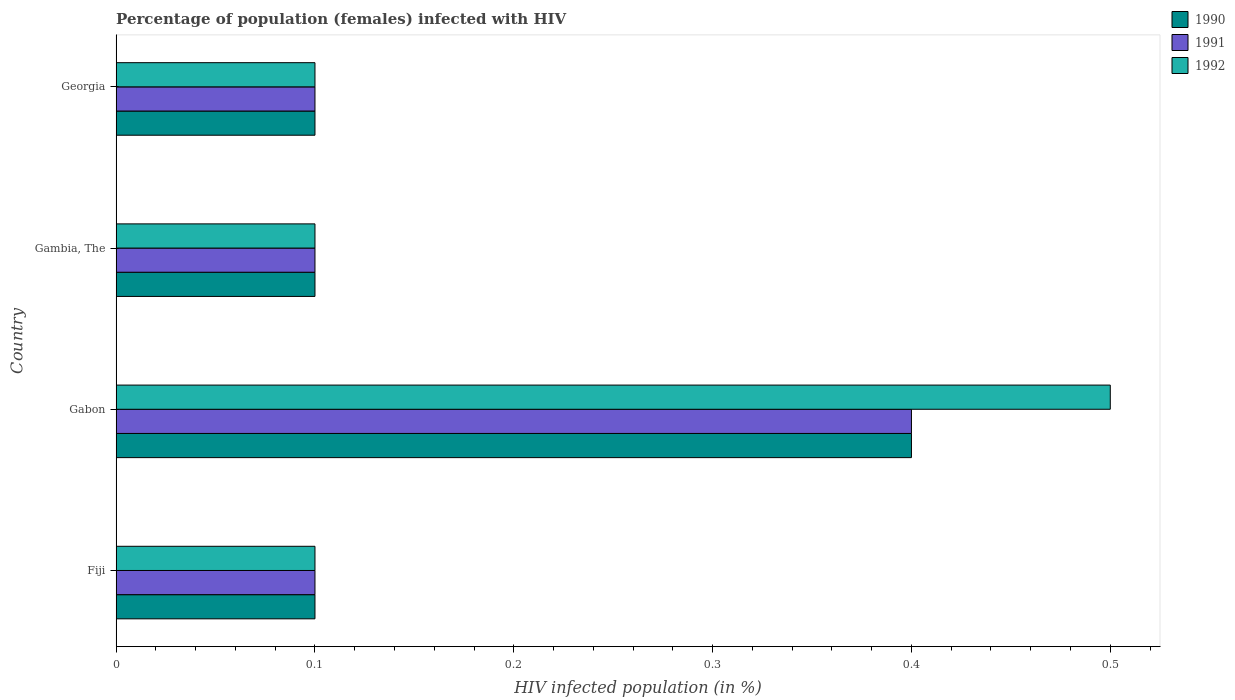How many different coloured bars are there?
Offer a terse response. 3. Are the number of bars on each tick of the Y-axis equal?
Offer a terse response. Yes. How many bars are there on the 1st tick from the bottom?
Offer a very short reply. 3. What is the label of the 4th group of bars from the top?
Your answer should be compact. Fiji. In how many cases, is the number of bars for a given country not equal to the number of legend labels?
Ensure brevity in your answer.  0. Across all countries, what is the minimum percentage of HIV infected female population in 1991?
Your response must be concise. 0.1. In which country was the percentage of HIV infected female population in 1990 maximum?
Make the answer very short. Gabon. In which country was the percentage of HIV infected female population in 1991 minimum?
Make the answer very short. Fiji. What is the total percentage of HIV infected female population in 1991 in the graph?
Your answer should be very brief. 0.7. What is the difference between the percentage of HIV infected female population in 1992 in Fiji and that in Gambia, The?
Your response must be concise. 0. What is the difference between the percentage of HIV infected female population in 1990 in Fiji and the percentage of HIV infected female population in 1991 in Georgia?
Make the answer very short. 0. What is the average percentage of HIV infected female population in 1992 per country?
Offer a terse response. 0.2. In how many countries, is the percentage of HIV infected female population in 1991 greater than 0.46 %?
Offer a terse response. 0. Is the difference between the percentage of HIV infected female population in 1990 in Fiji and Georgia greater than the difference between the percentage of HIV infected female population in 1992 in Fiji and Georgia?
Give a very brief answer. No. What is the difference between the highest and the second highest percentage of HIV infected female population in 1992?
Provide a succinct answer. 0.4. What is the difference between the highest and the lowest percentage of HIV infected female population in 1990?
Make the answer very short. 0.3. What does the 2nd bar from the bottom in Georgia represents?
Your response must be concise. 1991. Are all the bars in the graph horizontal?
Offer a very short reply. Yes. Are the values on the major ticks of X-axis written in scientific E-notation?
Your response must be concise. No. Does the graph contain any zero values?
Give a very brief answer. No. How many legend labels are there?
Your answer should be very brief. 3. How are the legend labels stacked?
Your response must be concise. Vertical. What is the title of the graph?
Your answer should be compact. Percentage of population (females) infected with HIV. Does "1967" appear as one of the legend labels in the graph?
Ensure brevity in your answer.  No. What is the label or title of the X-axis?
Give a very brief answer. HIV infected population (in %). What is the label or title of the Y-axis?
Make the answer very short. Country. What is the HIV infected population (in %) of 1990 in Fiji?
Offer a very short reply. 0.1. What is the HIV infected population (in %) in 1992 in Fiji?
Keep it short and to the point. 0.1. What is the HIV infected population (in %) of 1990 in Gabon?
Your answer should be very brief. 0.4. What is the HIV infected population (in %) of 1992 in Gabon?
Provide a succinct answer. 0.5. What is the HIV infected population (in %) in 1992 in Gambia, The?
Offer a very short reply. 0.1. What is the HIV infected population (in %) in 1992 in Georgia?
Offer a very short reply. 0.1. Across all countries, what is the maximum HIV infected population (in %) in 1990?
Your response must be concise. 0.4. Across all countries, what is the minimum HIV infected population (in %) of 1991?
Offer a terse response. 0.1. What is the total HIV infected population (in %) of 1990 in the graph?
Provide a short and direct response. 0.7. What is the total HIV infected population (in %) of 1991 in the graph?
Your response must be concise. 0.7. What is the total HIV infected population (in %) of 1992 in the graph?
Provide a succinct answer. 0.8. What is the difference between the HIV infected population (in %) of 1991 in Fiji and that in Gambia, The?
Give a very brief answer. 0. What is the difference between the HIV infected population (in %) of 1990 in Gabon and that in Gambia, The?
Ensure brevity in your answer.  0.3. What is the difference between the HIV infected population (in %) of 1991 in Gabon and that in Gambia, The?
Keep it short and to the point. 0.3. What is the difference between the HIV infected population (in %) in 1990 in Gabon and that in Georgia?
Provide a short and direct response. 0.3. What is the difference between the HIV infected population (in %) of 1991 in Fiji and the HIV infected population (in %) of 1992 in Gabon?
Your response must be concise. -0.4. What is the difference between the HIV infected population (in %) of 1990 in Fiji and the HIV infected population (in %) of 1992 in Gambia, The?
Offer a very short reply. 0. What is the difference between the HIV infected population (in %) in 1990 in Fiji and the HIV infected population (in %) in 1991 in Georgia?
Ensure brevity in your answer.  0. What is the difference between the HIV infected population (in %) in 1990 in Fiji and the HIV infected population (in %) in 1992 in Georgia?
Your response must be concise. 0. What is the difference between the HIV infected population (in %) of 1991 in Gabon and the HIV infected population (in %) of 1992 in Georgia?
Your answer should be very brief. 0.3. What is the difference between the HIV infected population (in %) of 1990 in Gambia, The and the HIV infected population (in %) of 1991 in Georgia?
Offer a very short reply. 0. What is the difference between the HIV infected population (in %) in 1990 in Gambia, The and the HIV infected population (in %) in 1992 in Georgia?
Your answer should be very brief. 0. What is the difference between the HIV infected population (in %) in 1991 in Gambia, The and the HIV infected population (in %) in 1992 in Georgia?
Keep it short and to the point. 0. What is the average HIV infected population (in %) of 1990 per country?
Make the answer very short. 0.17. What is the average HIV infected population (in %) in 1991 per country?
Your response must be concise. 0.17. What is the difference between the HIV infected population (in %) of 1990 and HIV infected population (in %) of 1992 in Fiji?
Ensure brevity in your answer.  0. What is the difference between the HIV infected population (in %) in 1990 and HIV infected population (in %) in 1991 in Gabon?
Ensure brevity in your answer.  0. What is the difference between the HIV infected population (in %) in 1990 and HIV infected population (in %) in 1992 in Gabon?
Keep it short and to the point. -0.1. What is the difference between the HIV infected population (in %) of 1991 and HIV infected population (in %) of 1992 in Gabon?
Your answer should be compact. -0.1. What is the difference between the HIV infected population (in %) in 1990 and HIV infected population (in %) in 1991 in Gambia, The?
Your answer should be very brief. 0. What is the difference between the HIV infected population (in %) of 1990 and HIV infected population (in %) of 1992 in Gambia, The?
Provide a short and direct response. 0. What is the difference between the HIV infected population (in %) of 1990 and HIV infected population (in %) of 1991 in Georgia?
Your answer should be compact. 0. What is the ratio of the HIV infected population (in %) in 1990 in Fiji to that in Gabon?
Ensure brevity in your answer.  0.25. What is the ratio of the HIV infected population (in %) in 1992 in Fiji to that in Gabon?
Provide a short and direct response. 0.2. What is the ratio of the HIV infected population (in %) in 1990 in Fiji to that in Georgia?
Make the answer very short. 1. What is the ratio of the HIV infected population (in %) of 1991 in Fiji to that in Georgia?
Ensure brevity in your answer.  1. What is the ratio of the HIV infected population (in %) of 1992 in Gabon to that in Gambia, The?
Offer a terse response. 5. What is the ratio of the HIV infected population (in %) in 1991 in Gabon to that in Georgia?
Provide a short and direct response. 4. What is the ratio of the HIV infected population (in %) of 1991 in Gambia, The to that in Georgia?
Your response must be concise. 1. What is the difference between the highest and the second highest HIV infected population (in %) of 1990?
Give a very brief answer. 0.3. What is the difference between the highest and the second highest HIV infected population (in %) of 1992?
Your answer should be compact. 0.4. What is the difference between the highest and the lowest HIV infected population (in %) of 1990?
Provide a succinct answer. 0.3. What is the difference between the highest and the lowest HIV infected population (in %) in 1991?
Make the answer very short. 0.3. 